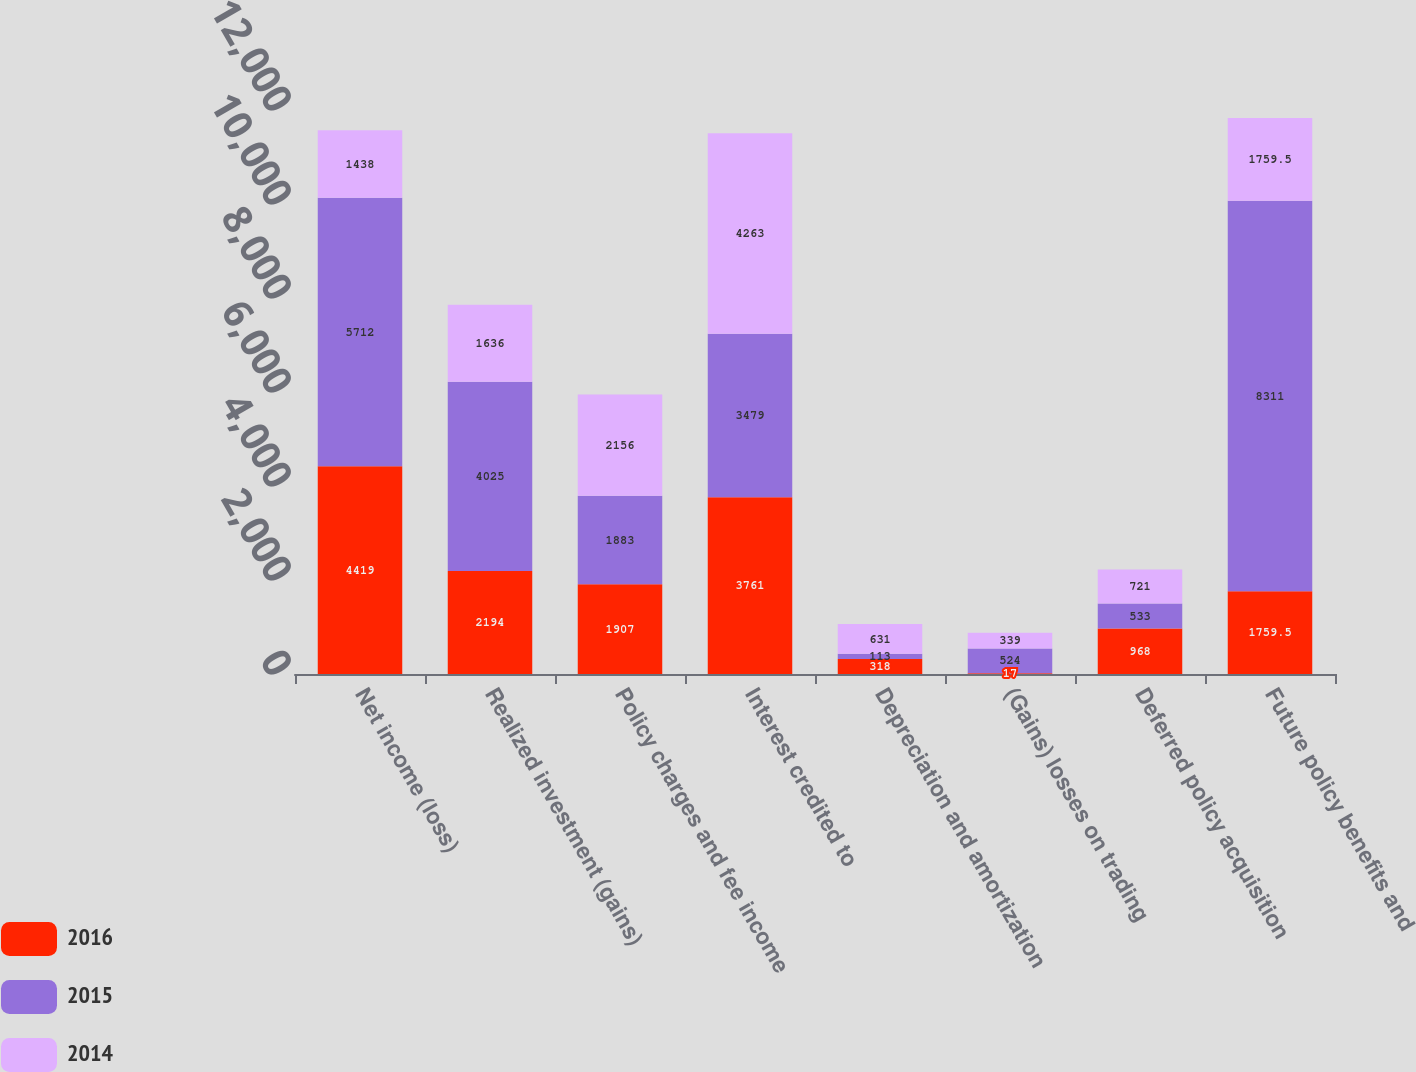<chart> <loc_0><loc_0><loc_500><loc_500><stacked_bar_chart><ecel><fcel>Net income (loss)<fcel>Realized investment (gains)<fcel>Policy charges and fee income<fcel>Interest credited to<fcel>Depreciation and amortization<fcel>(Gains) losses on trading<fcel>Deferred policy acquisition<fcel>Future policy benefits and<nl><fcel>2016<fcel>4419<fcel>2194<fcel>1907<fcel>3761<fcel>318<fcel>17<fcel>968<fcel>1759.5<nl><fcel>2015<fcel>5712<fcel>4025<fcel>1883<fcel>3479<fcel>113<fcel>524<fcel>533<fcel>8311<nl><fcel>2014<fcel>1438<fcel>1636<fcel>2156<fcel>4263<fcel>631<fcel>339<fcel>721<fcel>1759.5<nl></chart> 